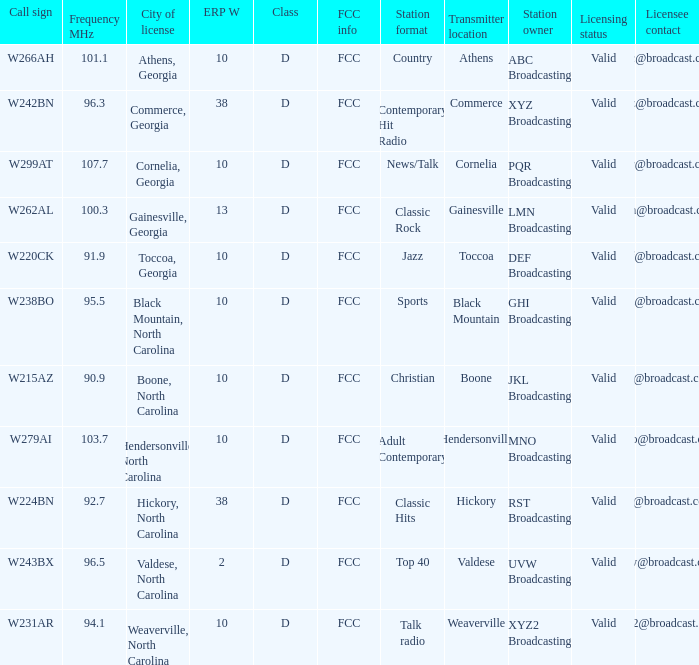What is the Frequency MHz for the station with a call sign of w224bn? 92.7. 